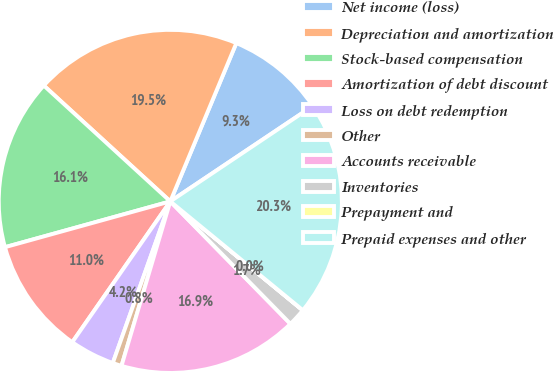<chart> <loc_0><loc_0><loc_500><loc_500><pie_chart><fcel>Net income (loss)<fcel>Depreciation and amortization<fcel>Stock-based compensation<fcel>Amortization of debt discount<fcel>Loss on debt redemption<fcel>Other<fcel>Accounts receivable<fcel>Inventories<fcel>Prepayment and<fcel>Prepaid expenses and other<nl><fcel>9.32%<fcel>19.49%<fcel>16.1%<fcel>11.02%<fcel>4.24%<fcel>0.85%<fcel>16.94%<fcel>1.7%<fcel>0.01%<fcel>20.33%<nl></chart> 